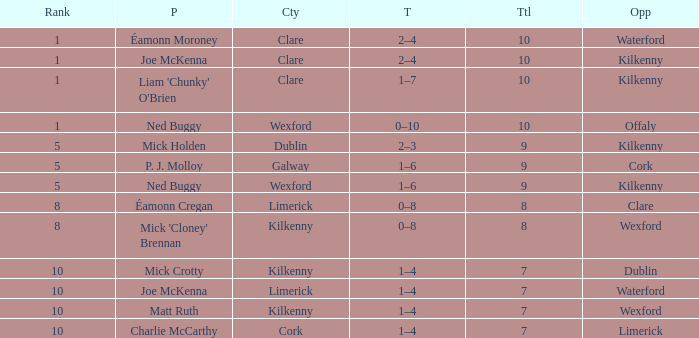Can you parse all the data within this table? {'header': ['Rank', 'P', 'Cty', 'T', 'Ttl', 'Opp'], 'rows': [['1', 'Éamonn Moroney', 'Clare', '2–4', '10', 'Waterford'], ['1', 'Joe McKenna', 'Clare', '2–4', '10', 'Kilkenny'], ['1', "Liam 'Chunky' O'Brien", 'Clare', '1–7', '10', 'Kilkenny'], ['1', 'Ned Buggy', 'Wexford', '0–10', '10', 'Offaly'], ['5', 'Mick Holden', 'Dublin', '2–3', '9', 'Kilkenny'], ['5', 'P. J. Molloy', 'Galway', '1–6', '9', 'Cork'], ['5', 'Ned Buggy', 'Wexford', '1–6', '9', 'Kilkenny'], ['8', 'Éamonn Cregan', 'Limerick', '0–8', '8', 'Clare'], ['8', "Mick 'Cloney' Brennan", 'Kilkenny', '0–8', '8', 'Wexford'], ['10', 'Mick Crotty', 'Kilkenny', '1–4', '7', 'Dublin'], ['10', 'Joe McKenna', 'Limerick', '1–4', '7', 'Waterford'], ['10', 'Matt Ruth', 'Kilkenny', '1–4', '7', 'Wexford'], ['10', 'Charlie McCarthy', 'Cork', '1–4', '7', 'Limerick']]} What is galway county's total? 9.0. 